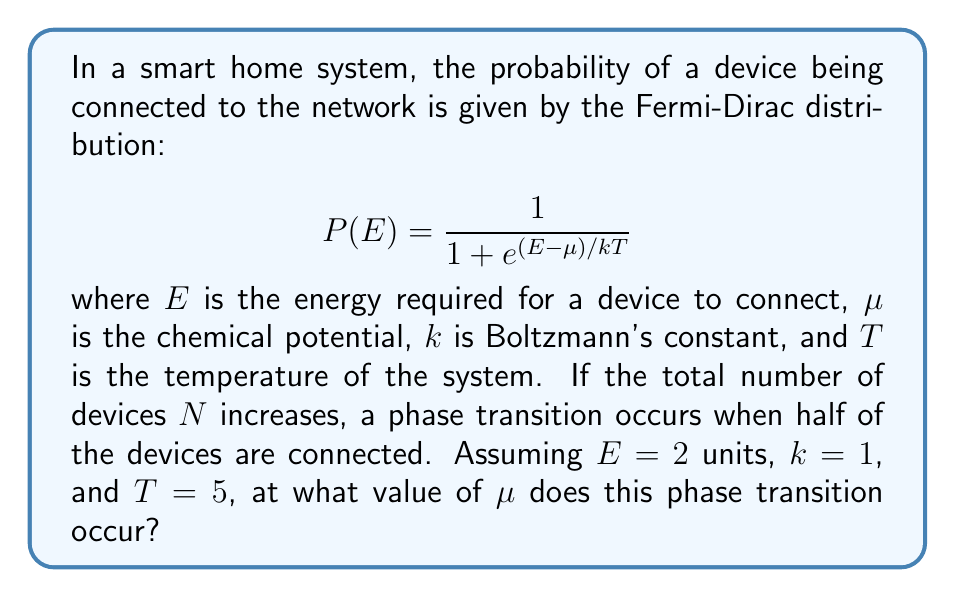Can you answer this question? To solve this problem, we'll follow these steps:

1) At the phase transition, half of the devices are connected. This means $P(E) = 0.5$.

2) We can substitute this into the Fermi-Dirac distribution equation:

   $$ 0.5 = \frac{1}{1 + e^{(E-\mu)/kT}} $$

3) Now, let's substitute the given values: $E = 2$, $k = 1$, and $T = 5$:

   $$ 0.5 = \frac{1}{1 + e^{(2-\mu)/5}} $$

4) To solve for $\mu$, first multiply both sides by the denominator:

   $$ 0.5(1 + e^{(2-\mu)/5}) = 1 $$

5) Expand the left side:

   $$ 0.5 + 0.5e^{(2-\mu)/5} = 1 $$

6) Subtract 0.5 from both sides:

   $$ 0.5e^{(2-\mu)/5} = 0.5 $$

7) Divide both sides by 0.5:

   $$ e^{(2-\mu)/5} = 1 $$

8) Take the natural log of both sides:

   $$ \frac{2-\mu}{5} = 0 $$

9) Multiply both sides by 5:

   $$ 2-\mu = 0 $$

10) Solve for $\mu$:

    $$ \mu = 2 $$

Therefore, the phase transition occurs when the chemical potential $\mu$ equals 2 units.
Answer: $\mu = 2$ units 